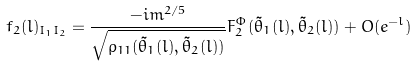<formula> <loc_0><loc_0><loc_500><loc_500>f _ { 2 } ( l ) _ { I _ { 1 } I _ { 2 } } = \frac { - i m ^ { 2 / 5 } } { \sqrt { \rho _ { 1 1 } ( \tilde { \theta } _ { 1 } ( l ) , \tilde { \theta } _ { 2 } ( l ) ) } } F _ { 2 } ^ { \Phi } ( \tilde { \theta } _ { 1 } ( l ) , \tilde { \theta } _ { 2 } ( l ) ) + O ( e ^ { - l } )</formula> 